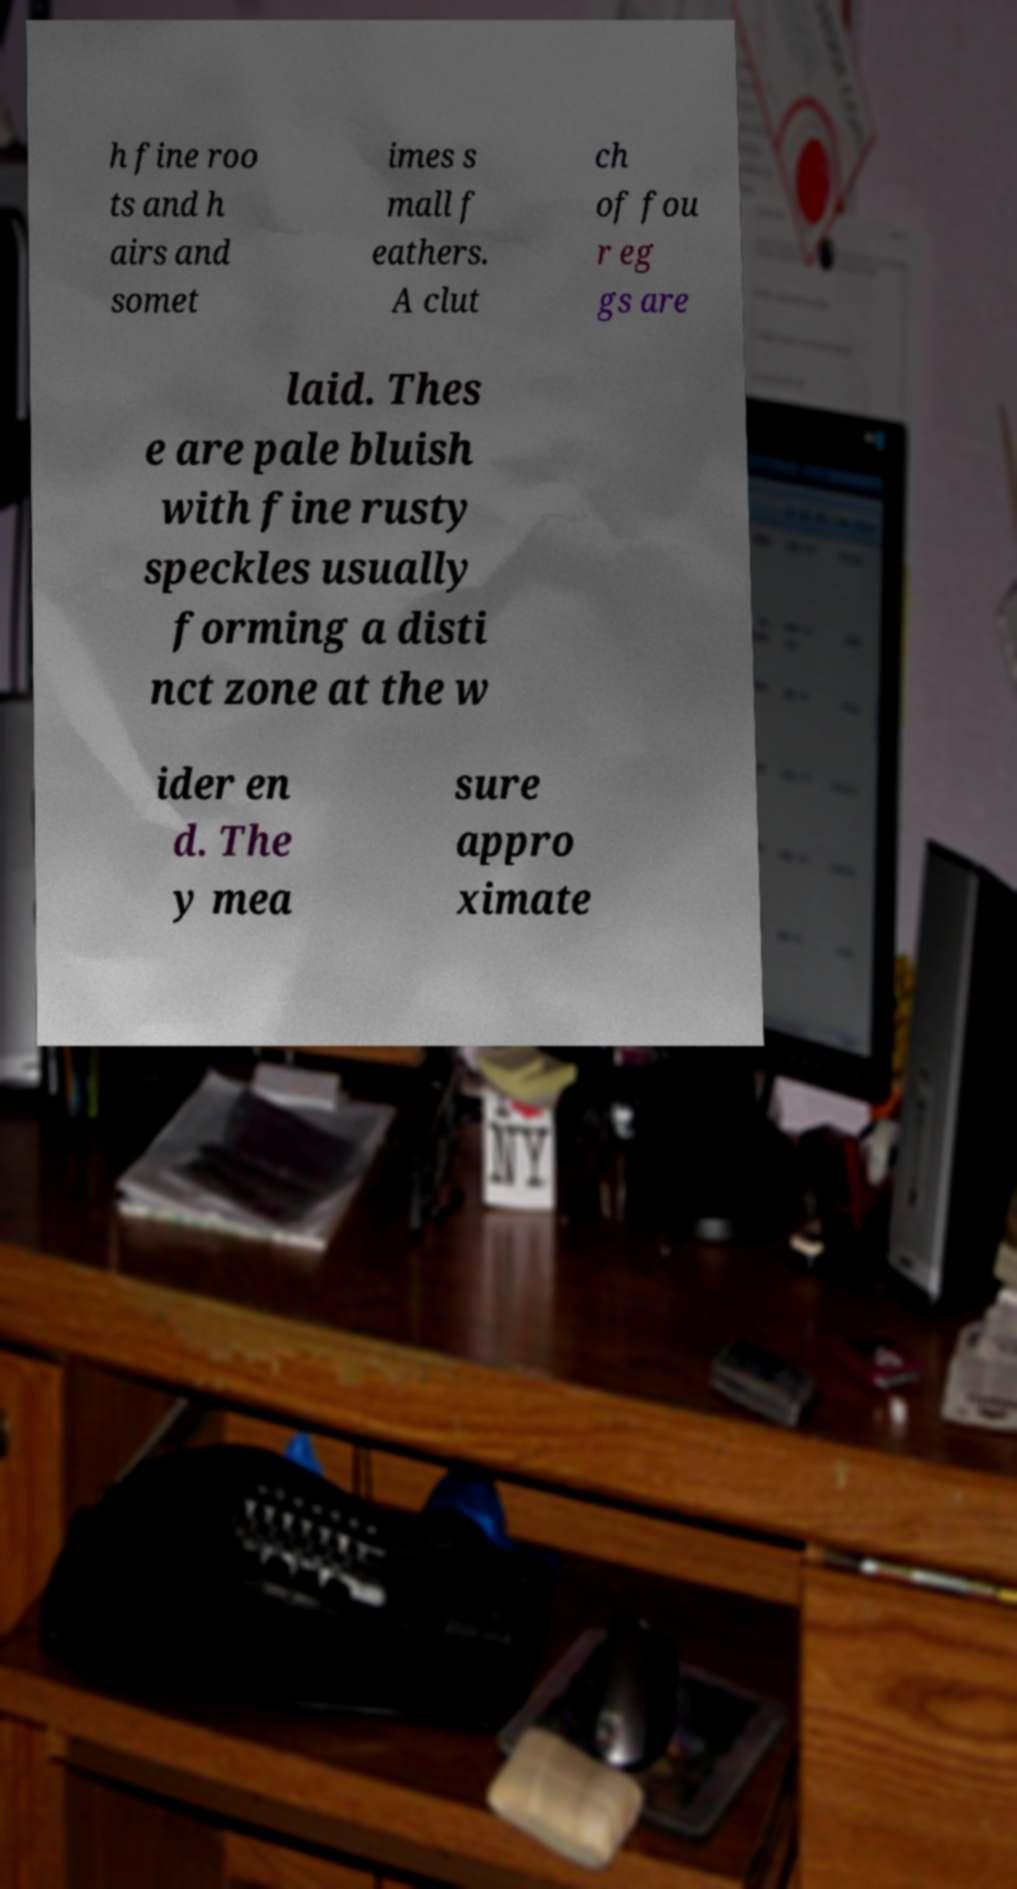Can you read and provide the text displayed in the image?This photo seems to have some interesting text. Can you extract and type it out for me? h fine roo ts and h airs and somet imes s mall f eathers. A clut ch of fou r eg gs are laid. Thes e are pale bluish with fine rusty speckles usually forming a disti nct zone at the w ider en d. The y mea sure appro ximate 